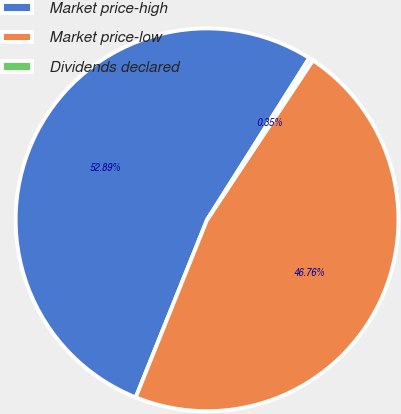Convert chart. <chart><loc_0><loc_0><loc_500><loc_500><pie_chart><fcel>Market price-high<fcel>Market price-low<fcel>Dividends declared<nl><fcel>52.89%<fcel>46.76%<fcel>0.35%<nl></chart> 